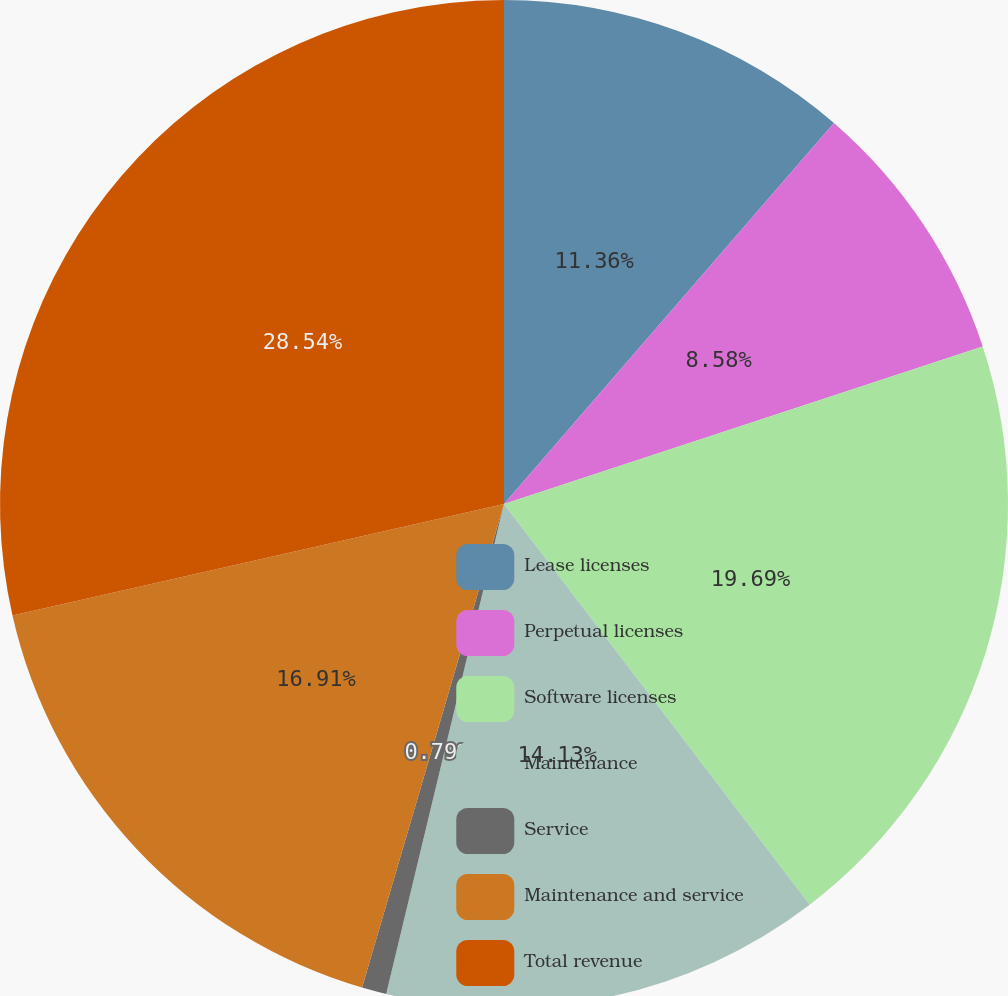Convert chart to OTSL. <chart><loc_0><loc_0><loc_500><loc_500><pie_chart><fcel>Lease licenses<fcel>Perpetual licenses<fcel>Software licenses<fcel>Maintenance<fcel>Service<fcel>Maintenance and service<fcel>Total revenue<nl><fcel>11.36%<fcel>8.58%<fcel>19.69%<fcel>14.13%<fcel>0.79%<fcel>16.91%<fcel>28.55%<nl></chart> 